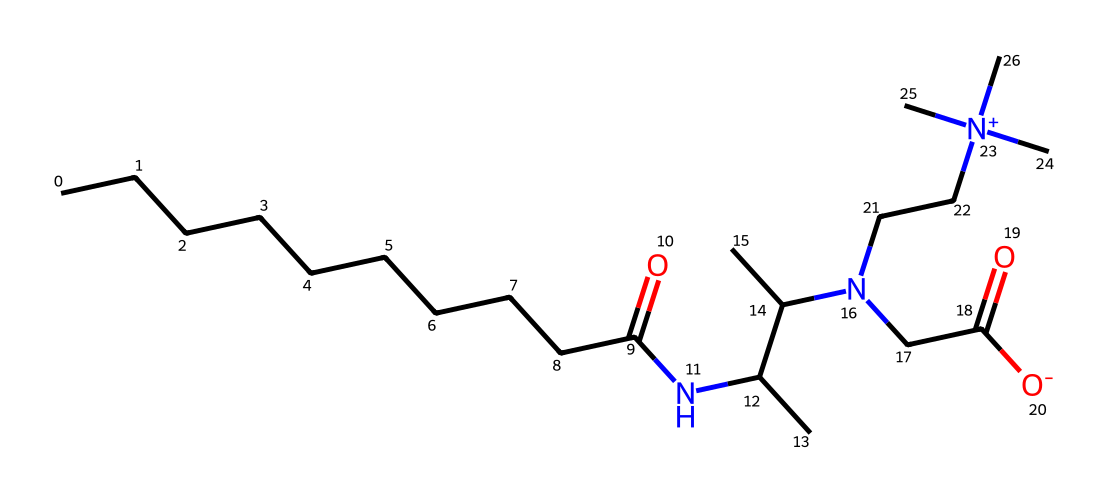What is the molecular formula of cocamidopropyl betaine? To find the molecular formula, we must identify the types and counts of atoms present in the SMILES representation. Analyzing the structure reveals the presence of carbon (C), hydrogen (H), nitrogen (N), and oxygen (O) atoms. Counting gives a total of 19 carbons, 38 hydrogens, 2 nitrogens, and 2 oxygens, leading to the molecular formula C19H38N2O2.
Answer: C19H38N2O2 How many nitrogen atoms are present in cocamidopropyl betaine? By analyzing the SMILES representation, we can identify direct symbols for nitrogen, which are represented by the letter 'N'. There are two 'N' atoms visible in the structure, indicating that cocamidopropyl betaine contains two nitrogen atoms.
Answer: 2 What functional groups are present in cocamidopropyl betaine? A functional group is a specific group of atoms that impart characteristic chemical properties. In this compound, we can identify an amide group (indicated by the carbonyl adjacent to nitrogen) and a quaternary ammonium group (visible from the nitrogen with a positive charge). These are key functional groups in cocamidopropyl betaine.
Answer: amide and quaternary ammonium What property makes cocamidopropyl betaine a good surfactant? The presence of both hydrophilic (water-attracting) and hydrophobic (water-repelling) parts in the structure creates an amphiphilic molecule. This enables it to reduce surface tension and interact well with both oil and water, which is essential for effective cleaning and emulsifying properties.
Answer: amphiphilic What does the presence of the quaternary nitrogen suggest about the charge of cocamidopropyl betaine? A quaternary nitrogen atom typically carries a positive charge due to having four carbon substituents. This positive charge is important for its behavior in aqueous solutions and its interaction with negatively charged surfaces (like dirt and grease), enhancing its effectiveness as a surfactant.
Answer: positive charge How does the carbon chain length affect the surfactant properties of cocamidopropyl betaine? The long carbon chain (10 carbons in this case) enhances the hydrophobic character of the molecule, improving its ability to solubilize oils and grease. Longer carbon chains generally lead to more effective wetting and emulsifying properties, making it a good choice for cleaning products.
Answer: improves hydrophobicity 